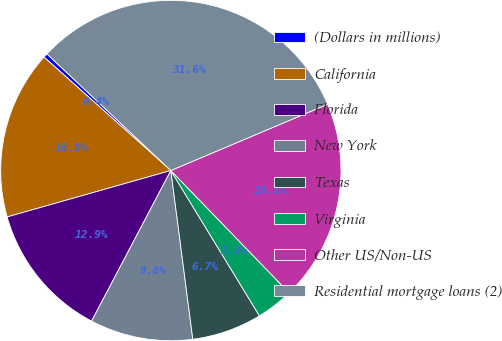<chart> <loc_0><loc_0><loc_500><loc_500><pie_chart><fcel>(Dollars in millions)<fcel>California<fcel>Florida<fcel>New York<fcel>Texas<fcel>Virginia<fcel>Other US/Non-US<fcel>Residential mortgage loans (2)<nl><fcel>0.4%<fcel>16.01%<fcel>12.89%<fcel>9.77%<fcel>6.65%<fcel>3.52%<fcel>19.13%<fcel>31.62%<nl></chart> 